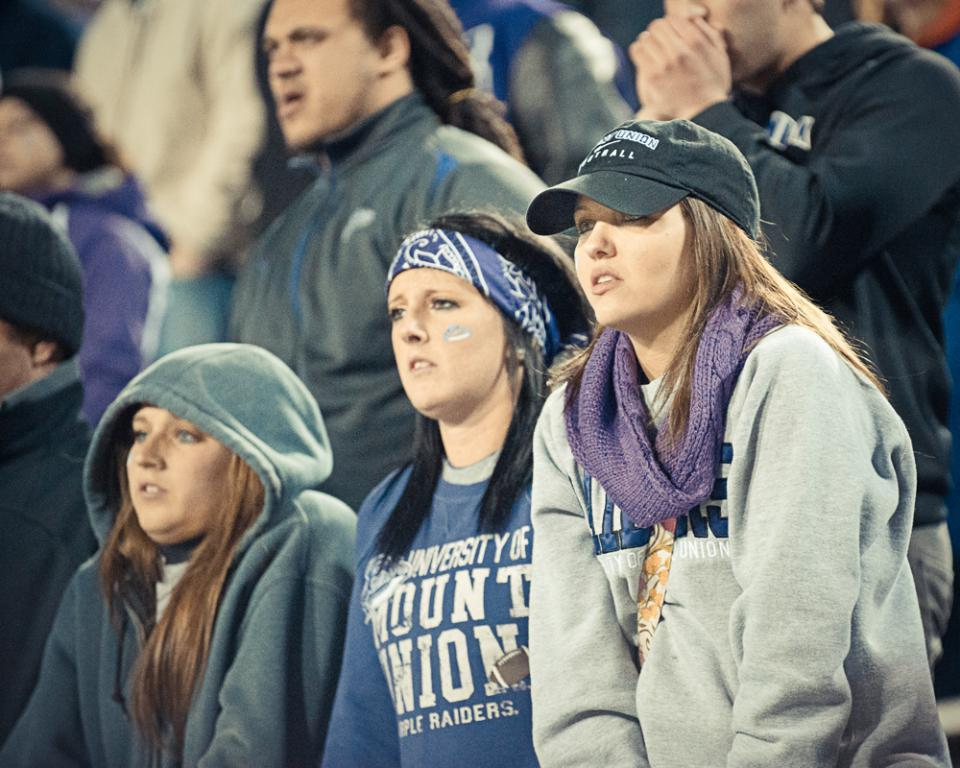How many people are in the image? There are persons in the image. What can be observed about the attire of the persons? The persons are wearing different color dresses. What is the posture of the persons in the image? The persons are standing. Can you describe the background of the image? The background of the image is blurred. What role does the manager play in the image? There is no mention of a manager in the image, so it is not possible to determine their role. 